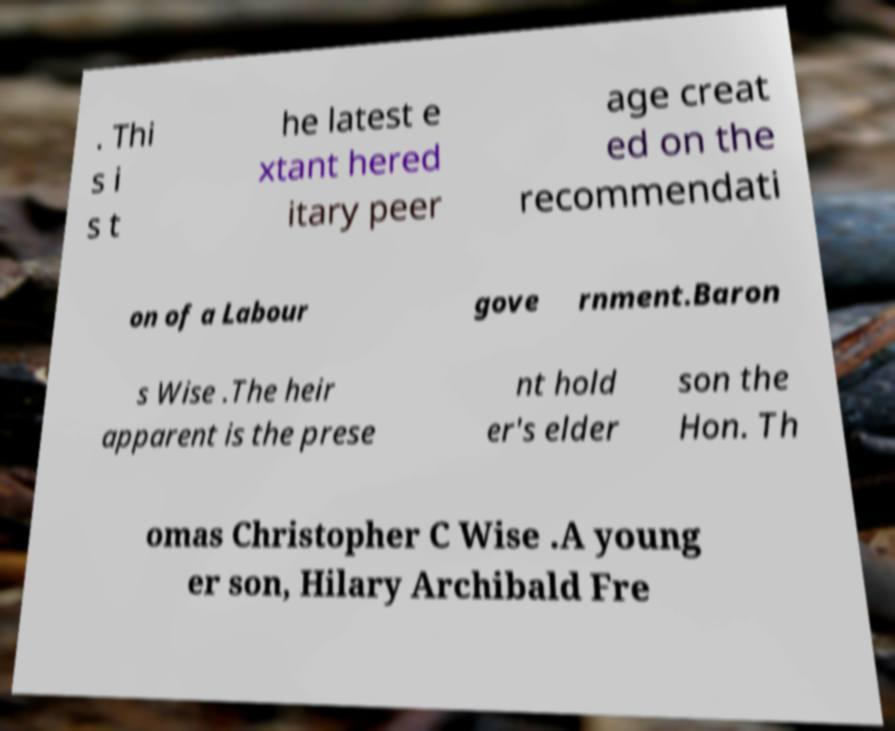Can you accurately transcribe the text from the provided image for me? . Thi s i s t he latest e xtant hered itary peer age creat ed on the recommendati on of a Labour gove rnment.Baron s Wise .The heir apparent is the prese nt hold er's elder son the Hon. Th omas Christopher C Wise .A young er son, Hilary Archibald Fre 